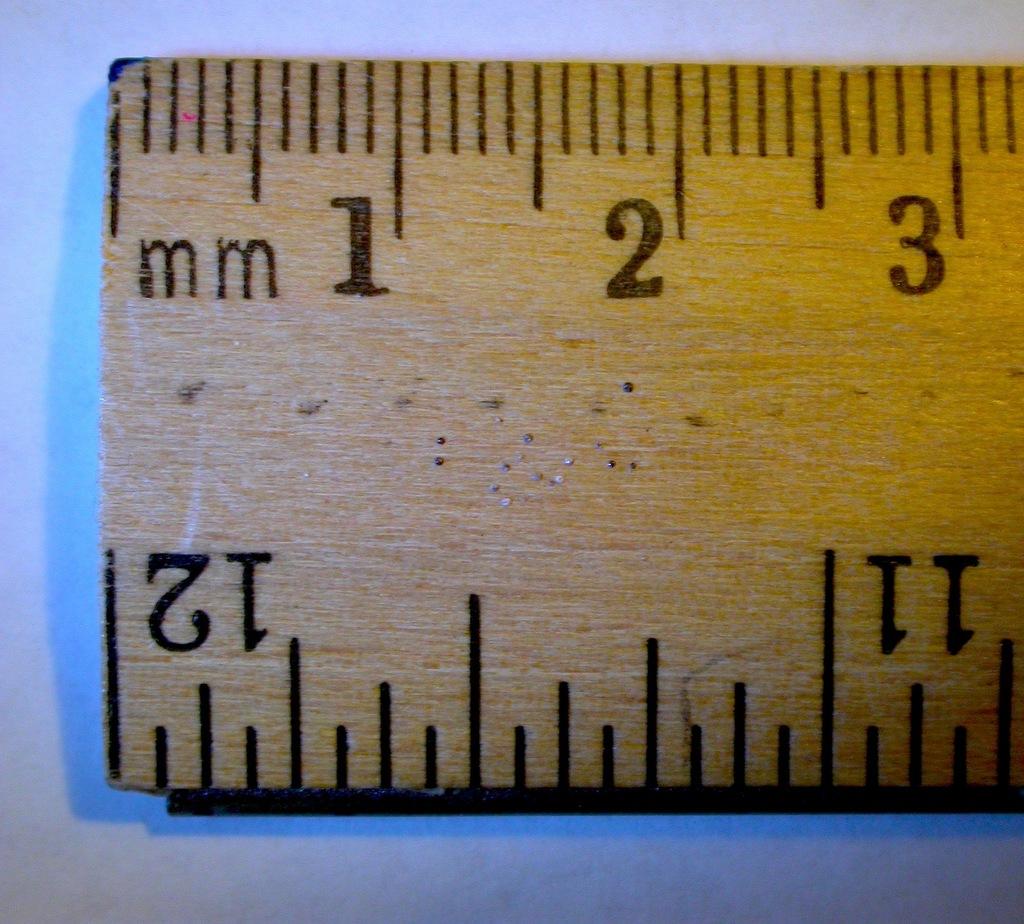What is the last inch on the ruler?
Provide a short and direct response. 12. What 2 letters are printed on the ruler?
Offer a terse response. Mm. 